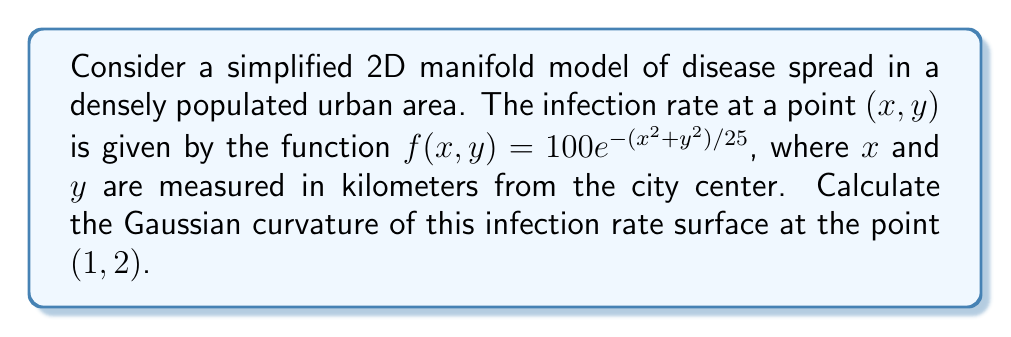Can you answer this question? To calculate the Gaussian curvature of the disease spread model on a 2D manifold, we'll follow these steps:

1) The Gaussian curvature $K$ at a point $(x, y)$ for a surface $z = f(x, y)$ is given by:

   $$K = \frac{f_{xx}f_{yy} - f_{xy}^2}{(1 + f_x^2 + f_y^2)^2}$$

   where $f_x$, $f_y$ are first partial derivatives, and $f_{xx}$, $f_{yy}$, $f_{xy}$ are second partial derivatives.

2) Let's calculate these derivatives:

   $f_x = \frac{\partial f}{\partial x} = 100e^{-(x^2+y^2)/25} \cdot (-\frac{2x}{25}) = -\frac{8x}{25}f$
   
   $f_y = \frac{\partial f}{\partial y} = 100e^{-(x^2+y^2)/25} \cdot (-\frac{2y}{25}) = -\frac{8y}{25}f$
   
   $f_{xx} = -\frac{8}{25}f - \frac{8x}{25}f_x = -\frac{8}{25}f + (\frac{8x}{25})^2f = f(\frac{64x^2}{625} - \frac{8}{25})$
   
   $f_{yy} = -\frac{8}{25}f - \frac{8y}{25}f_y = -\frac{8}{25}f + (\frac{8y}{25})^2f = f(\frac{64y^2}{625} - \frac{8}{25})$
   
   $f_{xy} = -\frac{8y}{25}f_x = \frac{64xy}{625}f$

3) Now, let's evaluate these at the point $(1, 2)$:

   $f(1, 2) = 100e^{-(1^2+2^2)/25} = 100e^{-0.2} \approx 81.87$
   
   $f_x(1, 2) = -\frac{8}{25} \cdot 81.87 \approx -26.20$
   
   $f_y(1, 2) = -\frac{16}{25} \cdot 81.87 \approx -52.40$
   
   $f_{xx}(1, 2) = 81.87(\frac{64}{625} - \frac{8}{25}) \approx -15.72$
   
   $f_{yy}(1, 2) = 81.87(\frac{256}{625} - \frac{8}{25}) \approx 5.24$
   
   $f_{xy}(1, 2) = \frac{64 \cdot 1 \cdot 2}{625} \cdot 81.87 \approx 16.76$

4) Now we can calculate the Gaussian curvature:

   $$K = \frac{f_{xx}f_{yy} - f_{xy}^2}{(1 + f_x^2 + f_y^2)^2}$$
   
   $$K = \frac{(-15.72)(5.24) - (16.76)^2}{(1 + (-26.20)^2 + (-52.40)^2)^2}$$
   
   $$K = \frac{-82.37 - 280.90}{(1 + 686.44 + 2745.76)^2} = \frac{-363.27}{3433.20^2}$$

5) Simplifying:

   $$K \approx -3.08 \times 10^{-5} \text{ km}^{-2}$$
Answer: The Gaussian curvature of the infection rate surface at the point $(1, 2)$ is approximately $-3.08 \times 10^{-5} \text{ km}^{-2}$. 